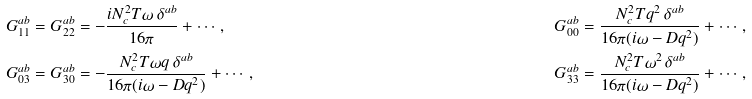<formula> <loc_0><loc_0><loc_500><loc_500>& G _ { 1 1 } ^ { a b } = G _ { 2 2 } ^ { a b } = - \frac { i N _ { c } ^ { 2 } T \omega \, \delta ^ { a b } } { 1 6 \pi } + \cdots \, , \quad & & G _ { 0 0 } ^ { a b } = \frac { N _ { c } ^ { 2 } T q ^ { 2 } \, \delta ^ { a b } } { 1 6 \pi ( i \omega - D q ^ { 2 } ) } + \cdots \, , \\ & G _ { 0 3 } ^ { a b } = G _ { 3 0 } ^ { a b } = - \frac { N _ { c } ^ { 2 } T \omega q \, \delta ^ { a b } } { 1 6 \pi ( i \omega - D q ^ { 2 } ) } + \cdots \, , \quad & & G _ { 3 3 } ^ { a b } = \frac { N _ { c } ^ { 2 } T \omega ^ { 2 } \, \delta ^ { a b } } { 1 6 \pi ( i \omega - D q ^ { 2 } ) } + \cdots ,</formula> 